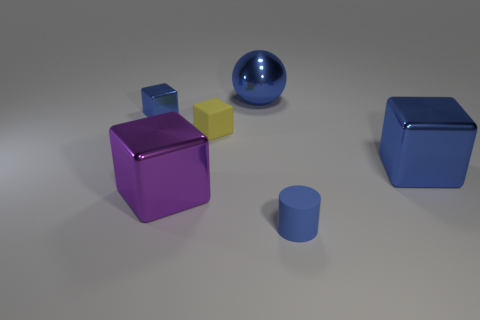What is the shape of the metal thing that is the same size as the yellow block?
Keep it short and to the point. Cube. Are there an equal number of large metal things that are behind the tiny yellow object and big things that are behind the purple block?
Provide a short and direct response. No. Are there any other things that are the same shape as the small blue metallic thing?
Keep it short and to the point. Yes. Are the big object behind the small yellow rubber object and the large purple object made of the same material?
Provide a short and direct response. Yes. There is a cylinder that is the same size as the yellow rubber block; what material is it?
Provide a short and direct response. Rubber. What number of other objects are the same material as the purple object?
Offer a very short reply. 3. Is the size of the yellow cube the same as the blue cube that is to the right of the rubber cube?
Provide a short and direct response. No. Is the number of big blue cubes in front of the big ball less than the number of purple things that are behind the big purple cube?
Keep it short and to the point. No. There is a metal block that is to the right of the small yellow cube; how big is it?
Offer a terse response. Large. Does the yellow block have the same size as the purple object?
Your answer should be very brief. No. 